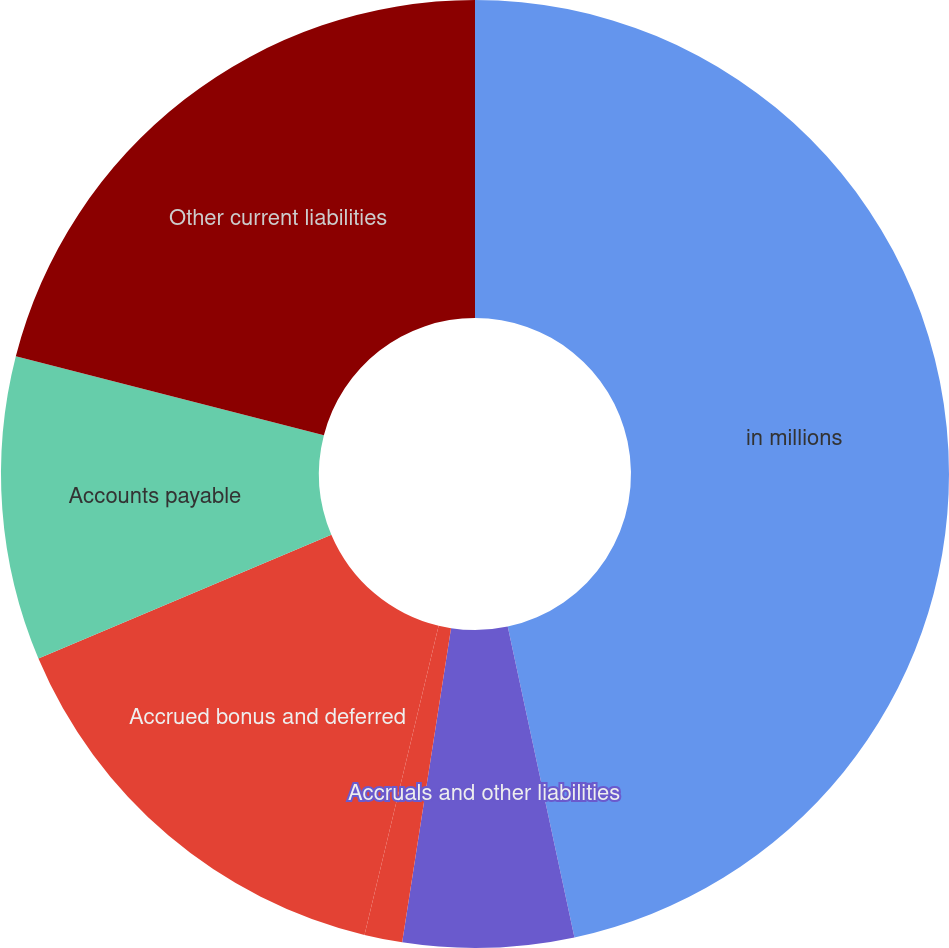<chart> <loc_0><loc_0><loc_500><loc_500><pie_chart><fcel>in millions<fcel>Accruals and other liabilities<fcel>Compensation and benefits<fcel>Accrued bonus and deferred<fcel>Accounts payable<fcel>Other current liabilities<nl><fcel>46.64%<fcel>5.82%<fcel>1.29%<fcel>14.89%<fcel>10.36%<fcel>21.01%<nl></chart> 